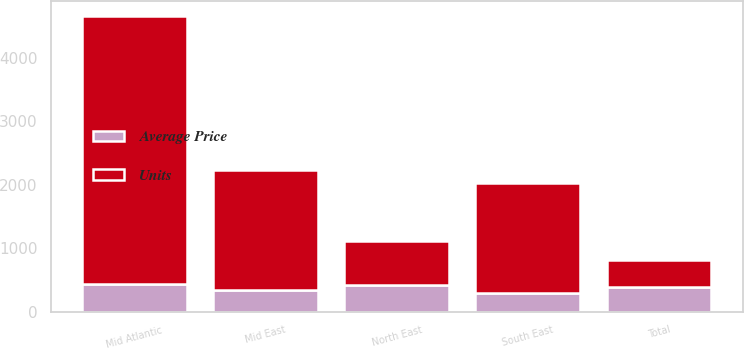Convert chart. <chart><loc_0><loc_0><loc_500><loc_500><stacked_bar_chart><ecel><fcel>Mid Atlantic<fcel>North East<fcel>Mid East<fcel>South East<fcel>Total<nl><fcel>Units<fcel>4224<fcel>682<fcel>1898<fcel>1727<fcel>432.2<nl><fcel>Average Price<fcel>432.2<fcel>424.3<fcel>341.2<fcel>298.4<fcel>384.2<nl></chart> 